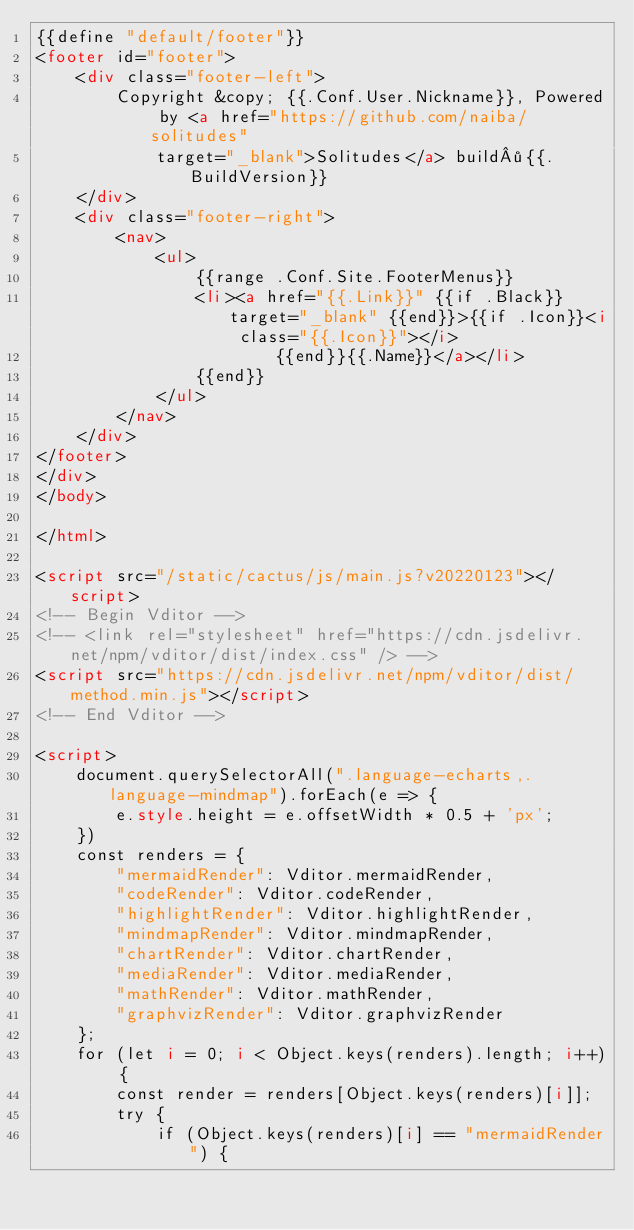<code> <loc_0><loc_0><loc_500><loc_500><_HTML_>{{define "default/footer"}}
<footer id="footer">
    <div class="footer-left">
        Copyright &copy; {{.Conf.User.Nickname}}, Powered by <a href="https://github.com/naiba/solitudes"
            target="_blank">Solitudes</a> build·{{.BuildVersion}}
    </div>
    <div class="footer-right">
        <nav>
            <ul>
                {{range .Conf.Site.FooterMenus}}
                <li><a href="{{.Link}}" {{if .Black}} target="_blank" {{end}}>{{if .Icon}}<i class="{{.Icon}}"></i>
                        {{end}}{{.Name}}</a></li>
                {{end}}
            </ul>
        </nav>
    </div>
</footer>
</div>
</body>

</html>

<script src="/static/cactus/js/main.js?v20220123"></script>
<!-- Begin Vditor -->
<!-- <link rel="stylesheet" href="https://cdn.jsdelivr.net/npm/vditor/dist/index.css" /> -->
<script src="https://cdn.jsdelivr.net/npm/vditor/dist/method.min.js"></script>
<!-- End Vditor -->

<script>
    document.querySelectorAll(".language-echarts,.language-mindmap").forEach(e => {
        e.style.height = e.offsetWidth * 0.5 + 'px';
    })
    const renders = {
        "mermaidRender": Vditor.mermaidRender,
        "codeRender": Vditor.codeRender,
        "highlightRender": Vditor.highlightRender,
        "mindmapRender": Vditor.mindmapRender,
        "chartRender": Vditor.chartRender,
        "mediaRender": Vditor.mediaRender,
        "mathRender": Vditor.mathRender,
        "graphvizRender": Vditor.graphvizRender
    };
    for (let i = 0; i < Object.keys(renders).length; i++) {
        const render = renders[Object.keys(renders)[i]];
        try {
            if (Object.keys(renders)[i] == "mermaidRender") {</code> 